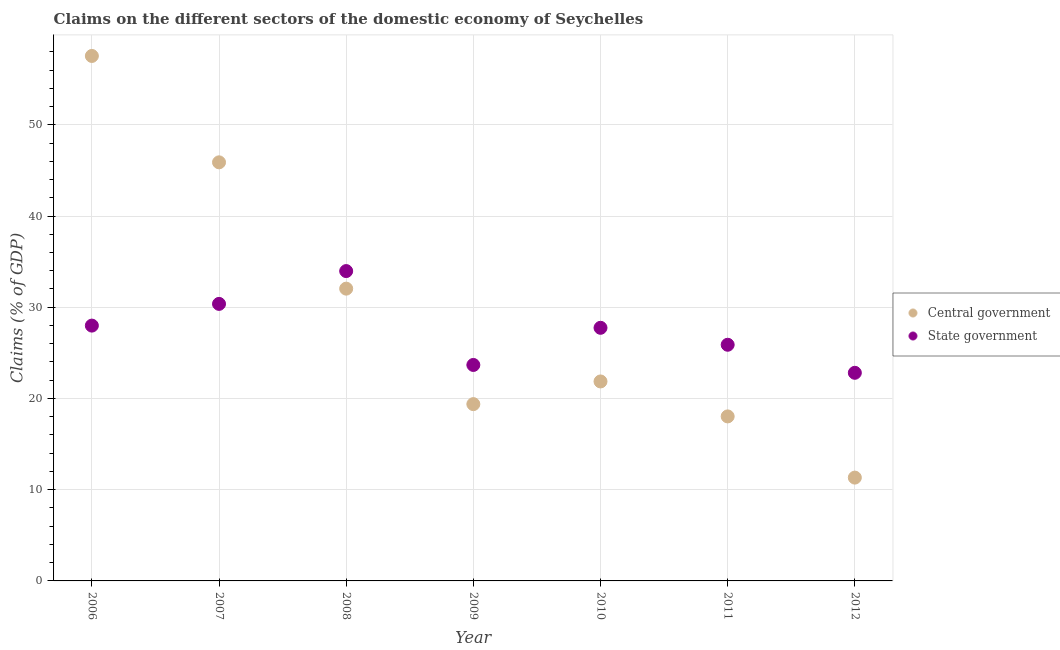What is the claims on state government in 2007?
Provide a succinct answer. 30.37. Across all years, what is the maximum claims on central government?
Provide a succinct answer. 57.54. Across all years, what is the minimum claims on central government?
Provide a succinct answer. 11.33. In which year was the claims on state government maximum?
Offer a terse response. 2008. What is the total claims on state government in the graph?
Keep it short and to the point. 192.44. What is the difference between the claims on state government in 2006 and that in 2007?
Provide a succinct answer. -2.38. What is the difference between the claims on central government in 2007 and the claims on state government in 2008?
Offer a very short reply. 11.92. What is the average claims on central government per year?
Your answer should be compact. 29.44. In the year 2012, what is the difference between the claims on state government and claims on central government?
Keep it short and to the point. 11.49. In how many years, is the claims on state government greater than 24 %?
Your answer should be very brief. 5. What is the ratio of the claims on central government in 2007 to that in 2010?
Keep it short and to the point. 2.1. Is the claims on central government in 2006 less than that in 2008?
Provide a succinct answer. No. Is the difference between the claims on state government in 2006 and 2012 greater than the difference between the claims on central government in 2006 and 2012?
Provide a short and direct response. No. What is the difference between the highest and the second highest claims on state government?
Give a very brief answer. 3.6. What is the difference between the highest and the lowest claims on central government?
Offer a very short reply. 46.22. In how many years, is the claims on central government greater than the average claims on central government taken over all years?
Ensure brevity in your answer.  3. Does the claims on central government monotonically increase over the years?
Offer a terse response. No. What is the difference between two consecutive major ticks on the Y-axis?
Keep it short and to the point. 10. How many legend labels are there?
Provide a succinct answer. 2. How are the legend labels stacked?
Keep it short and to the point. Vertical. What is the title of the graph?
Make the answer very short. Claims on the different sectors of the domestic economy of Seychelles. Does "Import" appear as one of the legend labels in the graph?
Your answer should be very brief. No. What is the label or title of the Y-axis?
Ensure brevity in your answer.  Claims (% of GDP). What is the Claims (% of GDP) in Central government in 2006?
Your answer should be compact. 57.54. What is the Claims (% of GDP) of State government in 2006?
Your answer should be compact. 27.99. What is the Claims (% of GDP) in Central government in 2007?
Give a very brief answer. 45.88. What is the Claims (% of GDP) of State government in 2007?
Your answer should be compact. 30.37. What is the Claims (% of GDP) of Central government in 2008?
Give a very brief answer. 32.04. What is the Claims (% of GDP) in State government in 2008?
Provide a succinct answer. 33.96. What is the Claims (% of GDP) in Central government in 2009?
Ensure brevity in your answer.  19.38. What is the Claims (% of GDP) of State government in 2009?
Your response must be concise. 23.67. What is the Claims (% of GDP) of Central government in 2010?
Provide a succinct answer. 21.87. What is the Claims (% of GDP) in State government in 2010?
Provide a succinct answer. 27.75. What is the Claims (% of GDP) in Central government in 2011?
Your response must be concise. 18.03. What is the Claims (% of GDP) of State government in 2011?
Offer a terse response. 25.89. What is the Claims (% of GDP) in Central government in 2012?
Ensure brevity in your answer.  11.33. What is the Claims (% of GDP) of State government in 2012?
Make the answer very short. 22.81. Across all years, what is the maximum Claims (% of GDP) in Central government?
Your response must be concise. 57.54. Across all years, what is the maximum Claims (% of GDP) in State government?
Provide a succinct answer. 33.96. Across all years, what is the minimum Claims (% of GDP) of Central government?
Keep it short and to the point. 11.33. Across all years, what is the minimum Claims (% of GDP) of State government?
Keep it short and to the point. 22.81. What is the total Claims (% of GDP) in Central government in the graph?
Offer a terse response. 206.07. What is the total Claims (% of GDP) of State government in the graph?
Give a very brief answer. 192.44. What is the difference between the Claims (% of GDP) in Central government in 2006 and that in 2007?
Your response must be concise. 11.66. What is the difference between the Claims (% of GDP) in State government in 2006 and that in 2007?
Your response must be concise. -2.38. What is the difference between the Claims (% of GDP) in Central government in 2006 and that in 2008?
Offer a terse response. 25.51. What is the difference between the Claims (% of GDP) in State government in 2006 and that in 2008?
Provide a succinct answer. -5.98. What is the difference between the Claims (% of GDP) of Central government in 2006 and that in 2009?
Keep it short and to the point. 38.16. What is the difference between the Claims (% of GDP) in State government in 2006 and that in 2009?
Ensure brevity in your answer.  4.31. What is the difference between the Claims (% of GDP) in Central government in 2006 and that in 2010?
Ensure brevity in your answer.  35.68. What is the difference between the Claims (% of GDP) of State government in 2006 and that in 2010?
Provide a short and direct response. 0.24. What is the difference between the Claims (% of GDP) of Central government in 2006 and that in 2011?
Offer a terse response. 39.51. What is the difference between the Claims (% of GDP) of State government in 2006 and that in 2011?
Offer a terse response. 2.1. What is the difference between the Claims (% of GDP) in Central government in 2006 and that in 2012?
Provide a succinct answer. 46.22. What is the difference between the Claims (% of GDP) of State government in 2006 and that in 2012?
Make the answer very short. 5.17. What is the difference between the Claims (% of GDP) in Central government in 2007 and that in 2008?
Make the answer very short. 13.85. What is the difference between the Claims (% of GDP) in State government in 2007 and that in 2008?
Provide a short and direct response. -3.6. What is the difference between the Claims (% of GDP) in Central government in 2007 and that in 2009?
Your response must be concise. 26.5. What is the difference between the Claims (% of GDP) of State government in 2007 and that in 2009?
Give a very brief answer. 6.69. What is the difference between the Claims (% of GDP) of Central government in 2007 and that in 2010?
Ensure brevity in your answer.  24.02. What is the difference between the Claims (% of GDP) in State government in 2007 and that in 2010?
Keep it short and to the point. 2.62. What is the difference between the Claims (% of GDP) of Central government in 2007 and that in 2011?
Give a very brief answer. 27.85. What is the difference between the Claims (% of GDP) of State government in 2007 and that in 2011?
Ensure brevity in your answer.  4.48. What is the difference between the Claims (% of GDP) of Central government in 2007 and that in 2012?
Make the answer very short. 34.56. What is the difference between the Claims (% of GDP) in State government in 2007 and that in 2012?
Keep it short and to the point. 7.55. What is the difference between the Claims (% of GDP) in Central government in 2008 and that in 2009?
Give a very brief answer. 12.66. What is the difference between the Claims (% of GDP) in State government in 2008 and that in 2009?
Offer a very short reply. 10.29. What is the difference between the Claims (% of GDP) in Central government in 2008 and that in 2010?
Make the answer very short. 10.17. What is the difference between the Claims (% of GDP) in State government in 2008 and that in 2010?
Provide a short and direct response. 6.22. What is the difference between the Claims (% of GDP) of Central government in 2008 and that in 2011?
Your answer should be compact. 14. What is the difference between the Claims (% of GDP) in State government in 2008 and that in 2011?
Make the answer very short. 8.08. What is the difference between the Claims (% of GDP) of Central government in 2008 and that in 2012?
Offer a very short reply. 20.71. What is the difference between the Claims (% of GDP) of State government in 2008 and that in 2012?
Provide a succinct answer. 11.15. What is the difference between the Claims (% of GDP) in Central government in 2009 and that in 2010?
Ensure brevity in your answer.  -2.49. What is the difference between the Claims (% of GDP) of State government in 2009 and that in 2010?
Offer a terse response. -4.07. What is the difference between the Claims (% of GDP) in Central government in 2009 and that in 2011?
Ensure brevity in your answer.  1.35. What is the difference between the Claims (% of GDP) in State government in 2009 and that in 2011?
Give a very brief answer. -2.21. What is the difference between the Claims (% of GDP) in Central government in 2009 and that in 2012?
Give a very brief answer. 8.06. What is the difference between the Claims (% of GDP) in State government in 2009 and that in 2012?
Provide a short and direct response. 0.86. What is the difference between the Claims (% of GDP) in Central government in 2010 and that in 2011?
Make the answer very short. 3.83. What is the difference between the Claims (% of GDP) in State government in 2010 and that in 2011?
Your answer should be compact. 1.86. What is the difference between the Claims (% of GDP) in Central government in 2010 and that in 2012?
Your answer should be very brief. 10.54. What is the difference between the Claims (% of GDP) of State government in 2010 and that in 2012?
Provide a short and direct response. 4.93. What is the difference between the Claims (% of GDP) in Central government in 2011 and that in 2012?
Your response must be concise. 6.71. What is the difference between the Claims (% of GDP) of State government in 2011 and that in 2012?
Ensure brevity in your answer.  3.07. What is the difference between the Claims (% of GDP) in Central government in 2006 and the Claims (% of GDP) in State government in 2007?
Your answer should be very brief. 27.18. What is the difference between the Claims (% of GDP) in Central government in 2006 and the Claims (% of GDP) in State government in 2008?
Your response must be concise. 23.58. What is the difference between the Claims (% of GDP) of Central government in 2006 and the Claims (% of GDP) of State government in 2009?
Offer a very short reply. 33.87. What is the difference between the Claims (% of GDP) of Central government in 2006 and the Claims (% of GDP) of State government in 2010?
Make the answer very short. 29.8. What is the difference between the Claims (% of GDP) of Central government in 2006 and the Claims (% of GDP) of State government in 2011?
Keep it short and to the point. 31.66. What is the difference between the Claims (% of GDP) in Central government in 2006 and the Claims (% of GDP) in State government in 2012?
Your response must be concise. 34.73. What is the difference between the Claims (% of GDP) of Central government in 2007 and the Claims (% of GDP) of State government in 2008?
Offer a terse response. 11.92. What is the difference between the Claims (% of GDP) of Central government in 2007 and the Claims (% of GDP) of State government in 2009?
Your answer should be compact. 22.21. What is the difference between the Claims (% of GDP) in Central government in 2007 and the Claims (% of GDP) in State government in 2010?
Provide a short and direct response. 18.14. What is the difference between the Claims (% of GDP) in Central government in 2007 and the Claims (% of GDP) in State government in 2011?
Your answer should be very brief. 20. What is the difference between the Claims (% of GDP) of Central government in 2007 and the Claims (% of GDP) of State government in 2012?
Keep it short and to the point. 23.07. What is the difference between the Claims (% of GDP) of Central government in 2008 and the Claims (% of GDP) of State government in 2009?
Your answer should be very brief. 8.37. What is the difference between the Claims (% of GDP) of Central government in 2008 and the Claims (% of GDP) of State government in 2010?
Provide a succinct answer. 4.29. What is the difference between the Claims (% of GDP) of Central government in 2008 and the Claims (% of GDP) of State government in 2011?
Provide a succinct answer. 6.15. What is the difference between the Claims (% of GDP) of Central government in 2008 and the Claims (% of GDP) of State government in 2012?
Your answer should be compact. 9.22. What is the difference between the Claims (% of GDP) of Central government in 2009 and the Claims (% of GDP) of State government in 2010?
Your answer should be compact. -8.37. What is the difference between the Claims (% of GDP) in Central government in 2009 and the Claims (% of GDP) in State government in 2011?
Offer a terse response. -6.51. What is the difference between the Claims (% of GDP) of Central government in 2009 and the Claims (% of GDP) of State government in 2012?
Your response must be concise. -3.43. What is the difference between the Claims (% of GDP) of Central government in 2010 and the Claims (% of GDP) of State government in 2011?
Provide a succinct answer. -4.02. What is the difference between the Claims (% of GDP) in Central government in 2010 and the Claims (% of GDP) in State government in 2012?
Provide a succinct answer. -0.95. What is the difference between the Claims (% of GDP) in Central government in 2011 and the Claims (% of GDP) in State government in 2012?
Your answer should be very brief. -4.78. What is the average Claims (% of GDP) of Central government per year?
Offer a terse response. 29.44. What is the average Claims (% of GDP) in State government per year?
Provide a short and direct response. 27.49. In the year 2006, what is the difference between the Claims (% of GDP) of Central government and Claims (% of GDP) of State government?
Give a very brief answer. 29.56. In the year 2007, what is the difference between the Claims (% of GDP) of Central government and Claims (% of GDP) of State government?
Offer a very short reply. 15.52. In the year 2008, what is the difference between the Claims (% of GDP) in Central government and Claims (% of GDP) in State government?
Your answer should be very brief. -1.93. In the year 2009, what is the difference between the Claims (% of GDP) of Central government and Claims (% of GDP) of State government?
Offer a terse response. -4.29. In the year 2010, what is the difference between the Claims (% of GDP) of Central government and Claims (% of GDP) of State government?
Keep it short and to the point. -5.88. In the year 2011, what is the difference between the Claims (% of GDP) of Central government and Claims (% of GDP) of State government?
Offer a terse response. -7.85. In the year 2012, what is the difference between the Claims (% of GDP) in Central government and Claims (% of GDP) in State government?
Keep it short and to the point. -11.49. What is the ratio of the Claims (% of GDP) in Central government in 2006 to that in 2007?
Provide a short and direct response. 1.25. What is the ratio of the Claims (% of GDP) in State government in 2006 to that in 2007?
Provide a succinct answer. 0.92. What is the ratio of the Claims (% of GDP) of Central government in 2006 to that in 2008?
Keep it short and to the point. 1.8. What is the ratio of the Claims (% of GDP) of State government in 2006 to that in 2008?
Ensure brevity in your answer.  0.82. What is the ratio of the Claims (% of GDP) in Central government in 2006 to that in 2009?
Provide a succinct answer. 2.97. What is the ratio of the Claims (% of GDP) of State government in 2006 to that in 2009?
Provide a short and direct response. 1.18. What is the ratio of the Claims (% of GDP) of Central government in 2006 to that in 2010?
Ensure brevity in your answer.  2.63. What is the ratio of the Claims (% of GDP) of State government in 2006 to that in 2010?
Your answer should be compact. 1.01. What is the ratio of the Claims (% of GDP) in Central government in 2006 to that in 2011?
Offer a very short reply. 3.19. What is the ratio of the Claims (% of GDP) in State government in 2006 to that in 2011?
Your answer should be compact. 1.08. What is the ratio of the Claims (% of GDP) of Central government in 2006 to that in 2012?
Provide a short and direct response. 5.08. What is the ratio of the Claims (% of GDP) in State government in 2006 to that in 2012?
Offer a terse response. 1.23. What is the ratio of the Claims (% of GDP) in Central government in 2007 to that in 2008?
Provide a succinct answer. 1.43. What is the ratio of the Claims (% of GDP) of State government in 2007 to that in 2008?
Your answer should be compact. 0.89. What is the ratio of the Claims (% of GDP) of Central government in 2007 to that in 2009?
Make the answer very short. 2.37. What is the ratio of the Claims (% of GDP) in State government in 2007 to that in 2009?
Provide a short and direct response. 1.28. What is the ratio of the Claims (% of GDP) of Central government in 2007 to that in 2010?
Provide a succinct answer. 2.1. What is the ratio of the Claims (% of GDP) in State government in 2007 to that in 2010?
Keep it short and to the point. 1.09. What is the ratio of the Claims (% of GDP) in Central government in 2007 to that in 2011?
Keep it short and to the point. 2.54. What is the ratio of the Claims (% of GDP) in State government in 2007 to that in 2011?
Your answer should be compact. 1.17. What is the ratio of the Claims (% of GDP) of Central government in 2007 to that in 2012?
Give a very brief answer. 4.05. What is the ratio of the Claims (% of GDP) in State government in 2007 to that in 2012?
Provide a succinct answer. 1.33. What is the ratio of the Claims (% of GDP) in Central government in 2008 to that in 2009?
Provide a succinct answer. 1.65. What is the ratio of the Claims (% of GDP) of State government in 2008 to that in 2009?
Give a very brief answer. 1.43. What is the ratio of the Claims (% of GDP) of Central government in 2008 to that in 2010?
Keep it short and to the point. 1.47. What is the ratio of the Claims (% of GDP) in State government in 2008 to that in 2010?
Your response must be concise. 1.22. What is the ratio of the Claims (% of GDP) of Central government in 2008 to that in 2011?
Your answer should be very brief. 1.78. What is the ratio of the Claims (% of GDP) in State government in 2008 to that in 2011?
Your answer should be very brief. 1.31. What is the ratio of the Claims (% of GDP) of Central government in 2008 to that in 2012?
Provide a succinct answer. 2.83. What is the ratio of the Claims (% of GDP) of State government in 2008 to that in 2012?
Keep it short and to the point. 1.49. What is the ratio of the Claims (% of GDP) in Central government in 2009 to that in 2010?
Offer a very short reply. 0.89. What is the ratio of the Claims (% of GDP) in State government in 2009 to that in 2010?
Offer a terse response. 0.85. What is the ratio of the Claims (% of GDP) of Central government in 2009 to that in 2011?
Ensure brevity in your answer.  1.07. What is the ratio of the Claims (% of GDP) in State government in 2009 to that in 2011?
Make the answer very short. 0.91. What is the ratio of the Claims (% of GDP) of Central government in 2009 to that in 2012?
Provide a short and direct response. 1.71. What is the ratio of the Claims (% of GDP) in State government in 2009 to that in 2012?
Your answer should be compact. 1.04. What is the ratio of the Claims (% of GDP) of Central government in 2010 to that in 2011?
Offer a very short reply. 1.21. What is the ratio of the Claims (% of GDP) of State government in 2010 to that in 2011?
Offer a very short reply. 1.07. What is the ratio of the Claims (% of GDP) in Central government in 2010 to that in 2012?
Ensure brevity in your answer.  1.93. What is the ratio of the Claims (% of GDP) in State government in 2010 to that in 2012?
Provide a succinct answer. 1.22. What is the ratio of the Claims (% of GDP) of Central government in 2011 to that in 2012?
Ensure brevity in your answer.  1.59. What is the ratio of the Claims (% of GDP) in State government in 2011 to that in 2012?
Offer a terse response. 1.13. What is the difference between the highest and the second highest Claims (% of GDP) in Central government?
Make the answer very short. 11.66. What is the difference between the highest and the second highest Claims (% of GDP) in State government?
Keep it short and to the point. 3.6. What is the difference between the highest and the lowest Claims (% of GDP) in Central government?
Your answer should be very brief. 46.22. What is the difference between the highest and the lowest Claims (% of GDP) of State government?
Offer a terse response. 11.15. 